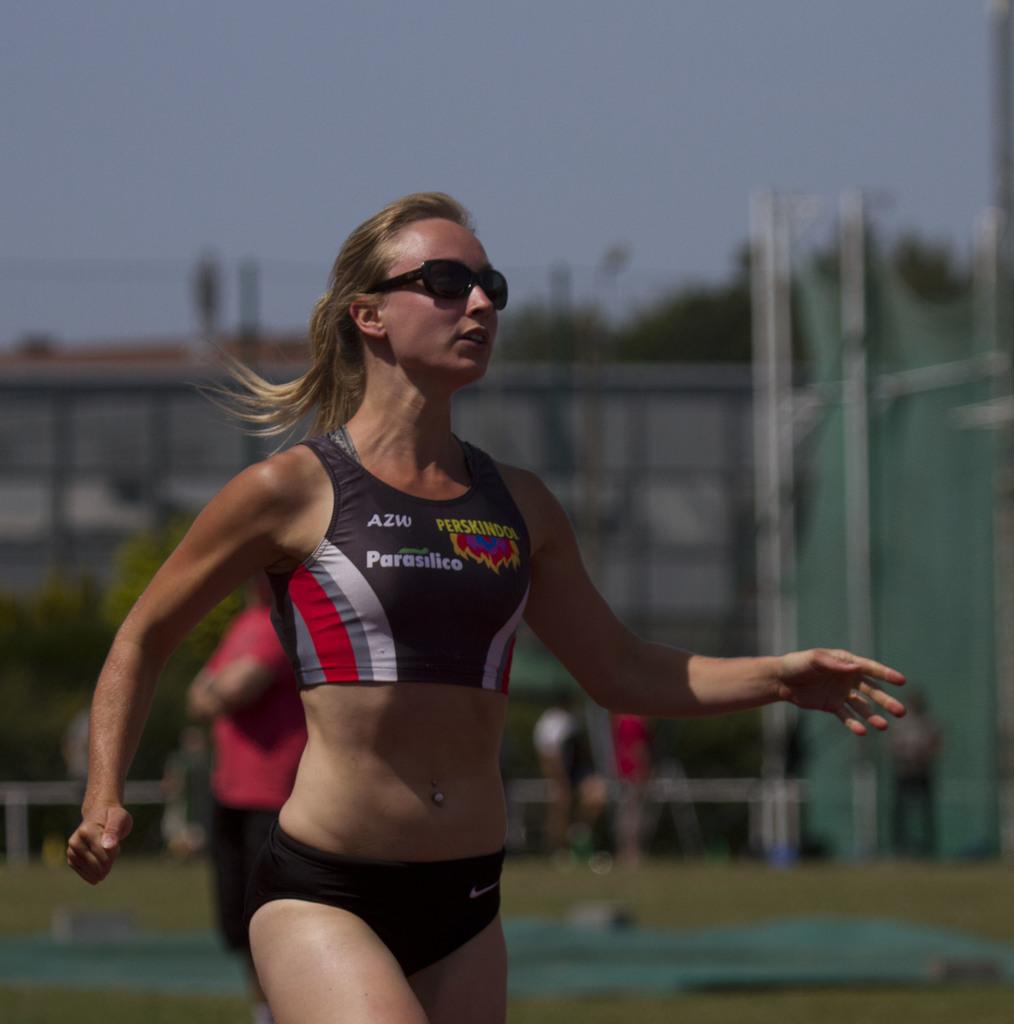What three letters are on the upper part of her shirt?
Keep it short and to the point. Azw. 